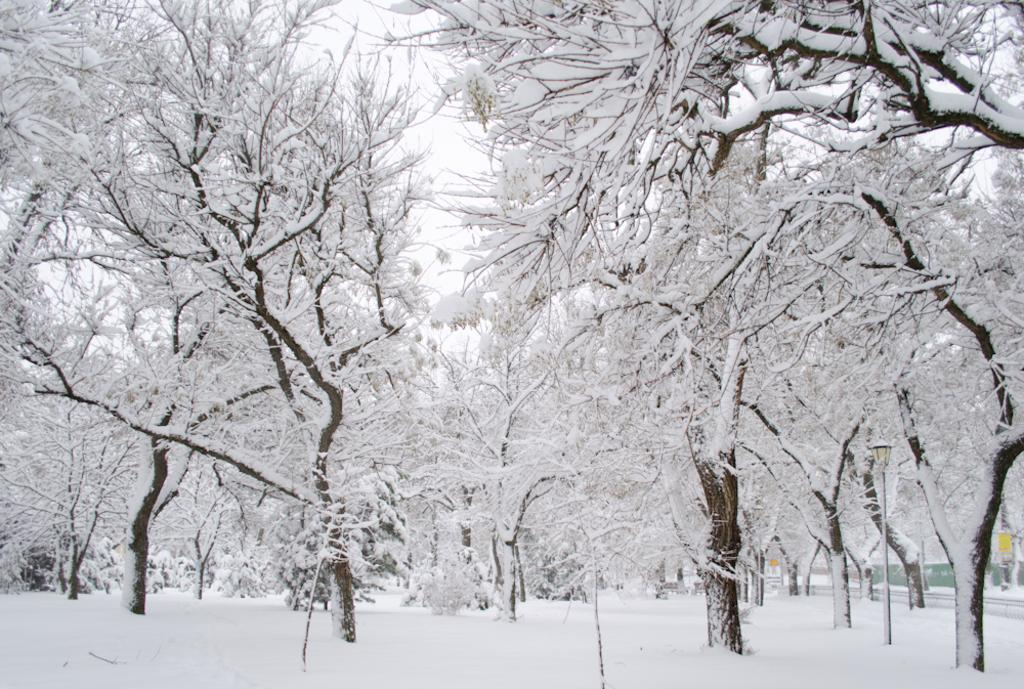What is the condition of the land in the image? The land is covered with snow in the image. What else is covered with snow in the image? The trees are covered with snow in the image. Can you describe the overall appearance of the image based on the snow coverage? The image depicts a snowy landscape with snow-covered trees. Where is the faucet located in the image? There is no faucet present in the image; it is a snowy landscape with snow-covered trees. What season is depicted in the image? The image does not specify a season, but the presence of snow suggests it could be winter. 